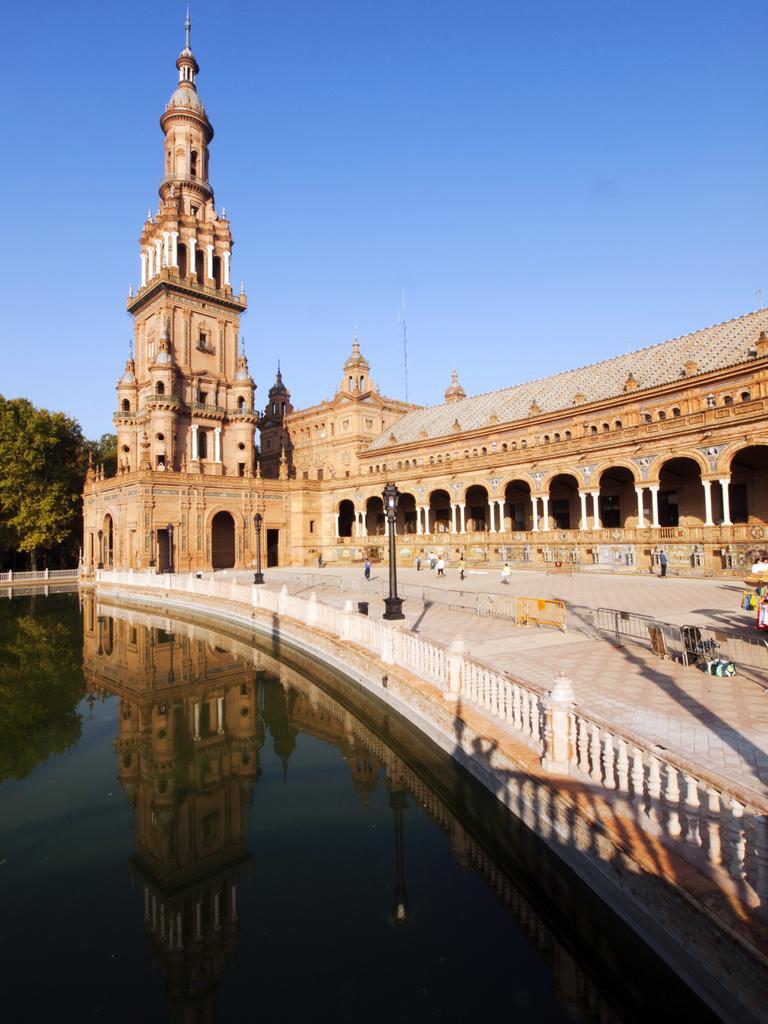Could you give a brief overview of what you see in this image? In the picture we can see a water and beside it, we can see a railing and behind it, we can see a path and a historical building with some part tower building and behind it we can see a tree and a sky. 